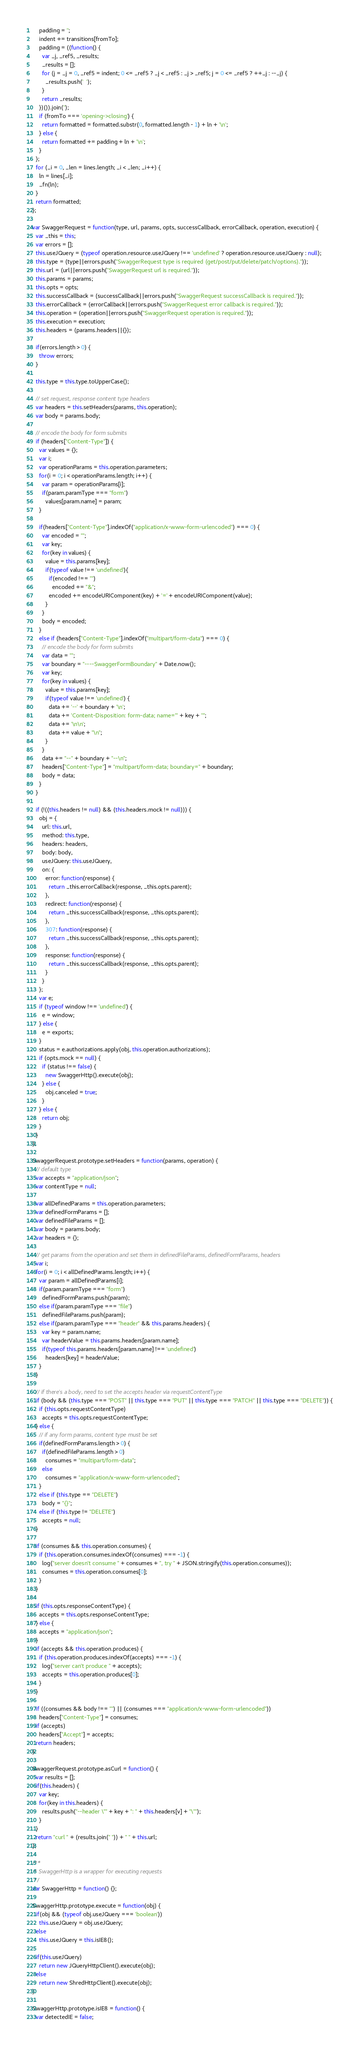<code> <loc_0><loc_0><loc_500><loc_500><_JavaScript_>    padding = '';
    indent += transitions[fromTo];
    padding = ((function() {
      var _j, _ref5, _results;
      _results = [];
      for (j = _j = 0, _ref5 = indent; 0 <= _ref5 ? _j < _ref5 : _j > _ref5; j = 0 <= _ref5 ? ++_j : --_j) {
        _results.push('  ');
      }
      return _results;
    })()).join('');
    if (fromTo === 'opening->closing') {
      return formatted = formatted.substr(0, formatted.length - 1) + ln + '\n';
    } else {
      return formatted += padding + ln + '\n';
    }
  };
  for (_i = 0, _len = lines.length; _i < _len; _i++) {
    ln = lines[_i];
    _fn(ln);
  }
  return formatted;
};

var SwaggerRequest = function(type, url, params, opts, successCallback, errorCallback, operation, execution) {
  var _this = this;
  var errors = [];
  this.useJQuery = (typeof operation.resource.useJQuery !== 'undefined' ? operation.resource.useJQuery : null);
  this.type = (type||errors.push("SwaggerRequest type is required (get/post/put/delete/patch/options)."));
  this.url = (url||errors.push("SwaggerRequest url is required."));
  this.params = params;
  this.opts = opts;
  this.successCallback = (successCallback||errors.push("SwaggerRequest successCallback is required."));
  this.errorCallback = (errorCallback||errors.push("SwaggerRequest error callback is required."));
  this.operation = (operation||errors.push("SwaggerRequest operation is required."));
  this.execution = execution;
  this.headers = (params.headers||{});

  if(errors.length > 0) {
    throw errors;
  }

  this.type = this.type.toUpperCase();

  // set request, response content type headers
  var headers = this.setHeaders(params, this.operation);
  var body = params.body;

  // encode the body for form submits
  if (headers["Content-Type"]) {
    var values = {};
    var i;
    var operationParams = this.operation.parameters;
    for(i = 0; i < operationParams.length; i++) {
      var param = operationParams[i];
      if(param.paramType === "form")
        values[param.name] = param;
    }

    if(headers["Content-Type"].indexOf("application/x-www-form-urlencoded") === 0) {
      var encoded = "";
      var key;
      for(key in values) {
        value = this.params[key];
        if(typeof value !== 'undefined'){
          if(encoded !== "")
            encoded += "&";
          encoded += encodeURIComponent(key) + '=' + encodeURIComponent(value);
        }
      }
      body = encoded;
    }
    else if (headers["Content-Type"].indexOf("multipart/form-data") === 0) {
      // encode the body for form submits
      var data = "";
      var boundary = "----SwaggerFormBoundary" + Date.now();
      var key;
      for(key in values) {
        value = this.params[key];
        if(typeof value !== 'undefined') {
          data += '--' + boundary + '\n';
          data += 'Content-Disposition: form-data; name="' + key + '"';
          data += '\n\n';
          data += value + "\n";
        }
      }
      data += "--" + boundary + "--\n";
      headers["Content-Type"] = "multipart/form-data; boundary=" + boundary;
      body = data;
    }
  }

  if (!((this.headers != null) && (this.headers.mock != null))) {
    obj = {
      url: this.url,
      method: this.type,
      headers: headers,
      body: body,
      useJQuery: this.useJQuery,
      on: {
        error: function(response) {
          return _this.errorCallback(response, _this.opts.parent);
        },
        redirect: function(response) {
          return _this.successCallback(response, _this.opts.parent);
        },
        307: function(response) {
          return _this.successCallback(response, _this.opts.parent);
        },
        response: function(response) {
          return _this.successCallback(response, _this.opts.parent);
        }
      }
    };
    var e;
    if (typeof window !== 'undefined') {
      e = window;
    } else {
      e = exports;
    }
    status = e.authorizations.apply(obj, this.operation.authorizations);
    if (opts.mock == null) {
      if (status !== false) {
        new SwaggerHttp().execute(obj);
      } else {
        obj.canceled = true;
      }
    } else {
      return obj;
    }
  }
};

SwaggerRequest.prototype.setHeaders = function(params, operation) {
  // default type
  var accepts = "application/json";
  var contentType = null;

  var allDefinedParams = this.operation.parameters;
  var definedFormParams = [];
  var definedFileParams = [];
  var body = params.body;
  var headers = {};

  // get params from the operation and set them in definedFileParams, definedFormParams, headers
  var i;
  for(i = 0; i < allDefinedParams.length; i++) {
    var param = allDefinedParams[i];
    if(param.paramType === "form")
      definedFormParams.push(param);
    else if(param.paramType === "file")
      definedFileParams.push(param);
    else if(param.paramType === "header" && this.params.headers) {
      var key = param.name;
      var headerValue = this.params.headers[param.name];
      if(typeof this.params.headers[param.name] !== 'undefined')
        headers[key] = headerValue;
    }
  }

  // if there's a body, need to set the accepts header via requestContentType
  if (body && (this.type === "POST" || this.type === "PUT" || this.type === "PATCH" || this.type === "DELETE")) {
    if (this.opts.requestContentType)
      accepts = this.opts.requestContentType;
  } else {
    // if any form params, content type must be set
    if(definedFormParams.length > 0) {
      if(definedFileParams.length > 0)
        consumes = "multipart/form-data";
      else
        consumes = "application/x-www-form-urlencoded";
    }
    else if (this.type == "DELETE")
      body = "{}";
    else if (this.type != "DELETE")
      accepts = null;
  }

  if (consumes && this.operation.consumes) {
    if (this.operation.consumes.indexOf(consumes) === -1) {
      log("server doesn't consume " + consumes + ", try " + JSON.stringify(this.operation.consumes));
      consumes = this.operation.consumes[0];
    }
  }

  if (this.opts.responseContentType) {
    accepts = this.opts.responseContentType;
  } else {
    accepts = "application/json";
  }
  if (accepts && this.operation.produces) {
    if (this.operation.produces.indexOf(accepts) === -1) {
      log("server can't produce " + accepts);
      accepts = this.operation.produces[0];
    }
  }

  if ((consumes && body !== "") || (consumes === "application/x-www-form-urlencoded"))
    headers["Content-Type"] = consumes;
  if (accepts)
    headers["Accept"] = accepts;
  return headers;
}

SwaggerRequest.prototype.asCurl = function() {
  var results = [];
  if(this.headers) {
    var key;
    for(key in this.headers) {
      results.push("--header \"" + key + ": " + this.headers[v] + "\"");
    }
  }
  return "curl " + (results.join(" ")) + " " + this.url;
};

/**
 * SwaggerHttp is a wrapper for executing requests
 */
var SwaggerHttp = function() {};

SwaggerHttp.prototype.execute = function(obj) {
  if(obj && (typeof obj.useJQuery === 'boolean'))
    this.useJQuery = obj.useJQuery;
  else
    this.useJQuery = this.isIE8();

  if(this.useJQuery)
    return new JQueryHttpClient().execute(obj);
  else
    return new ShredHttpClient().execute(obj);
}

SwaggerHttp.prototype.isIE8 = function() {
  var detectedIE = false;</code> 